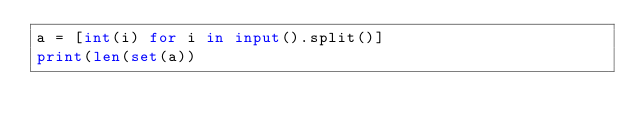Convert code to text. <code><loc_0><loc_0><loc_500><loc_500><_Python_>a = [int(i) for i in input().split()]
print(len(set(a))</code> 